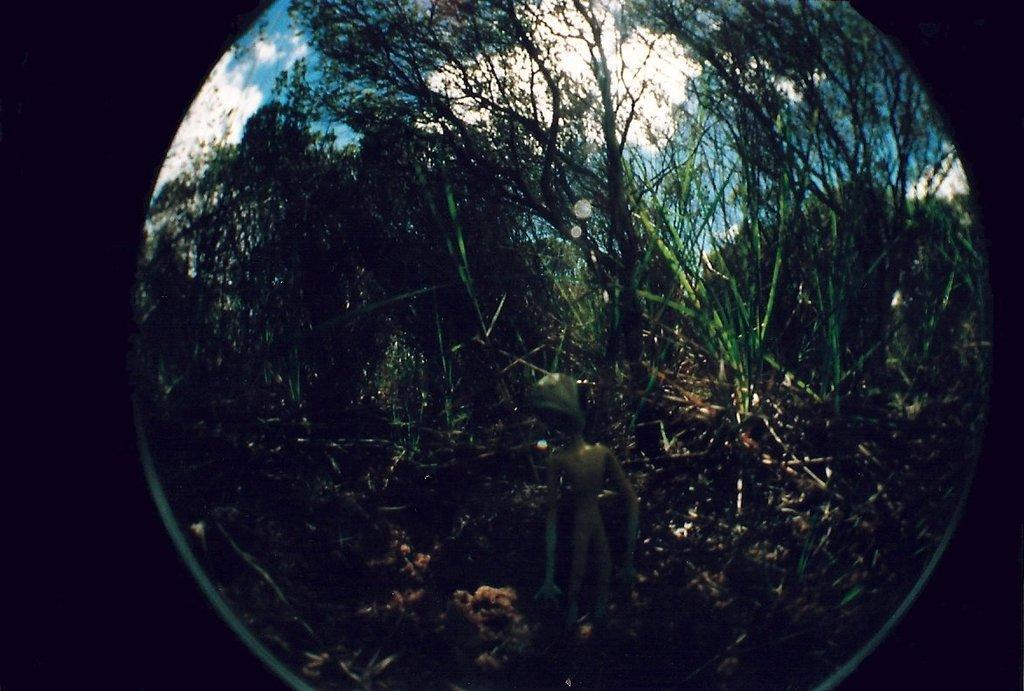What object is present in the image that has a transparent surface? There is a glass in the image. What can be seen through the glass in the image? Trees, clouds, and the sky are visible through the glass in the image. What type of mine is visible through the glass in the image? There is no mine visible through the glass in the image; it only shows trees, clouds, and the sky. 